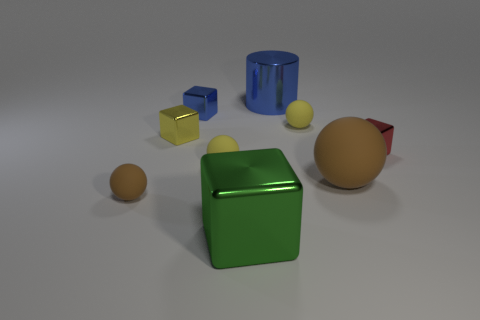There is a large rubber sphere; is its color the same as the big metal thing that is in front of the small brown rubber thing?
Your response must be concise. No. What number of objects are either yellow shiny blocks or brown spheres that are on the left side of the big matte ball?
Make the answer very short. 2. There is a matte sphere behind the tiny metal cube that is on the right side of the small blue shiny thing; how big is it?
Your answer should be very brief. Small. Are there the same number of large green things that are to the left of the tiny blue block and small rubber spheres in front of the big brown rubber object?
Offer a terse response. No. There is a blue cube on the left side of the small red shiny object; are there any tiny yellow balls behind it?
Make the answer very short. No. There is a big blue object that is made of the same material as the tiny red cube; what shape is it?
Your response must be concise. Cylinder. Are there any other things of the same color as the large matte ball?
Keep it short and to the point. Yes. What is the small sphere that is to the left of the tiny yellow rubber thing left of the metal cylinder made of?
Provide a succinct answer. Rubber. Is there a tiny blue metal thing that has the same shape as the big rubber object?
Offer a very short reply. No. How many other objects are there of the same shape as the small brown rubber thing?
Ensure brevity in your answer.  3. 